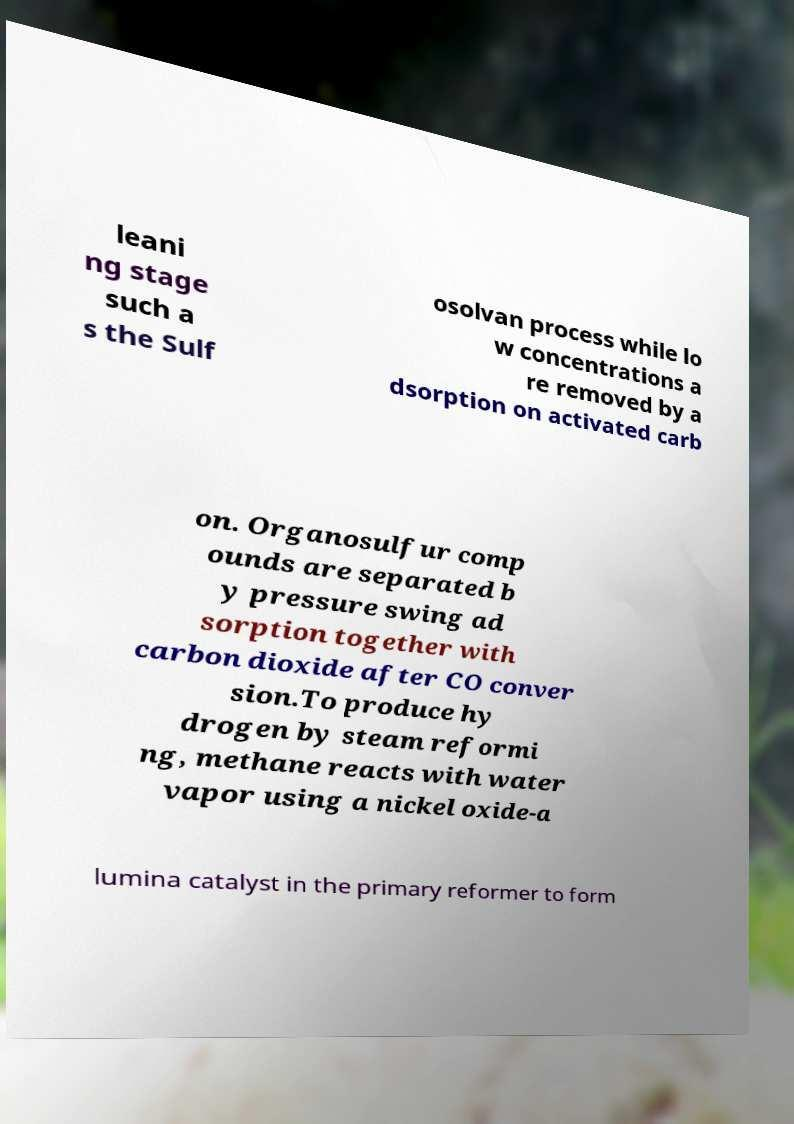Could you extract and type out the text from this image? leani ng stage such a s the Sulf osolvan process while lo w concentrations a re removed by a dsorption on activated carb on. Organosulfur comp ounds are separated b y pressure swing ad sorption together with carbon dioxide after CO conver sion.To produce hy drogen by steam reformi ng, methane reacts with water vapor using a nickel oxide-a lumina catalyst in the primary reformer to form 